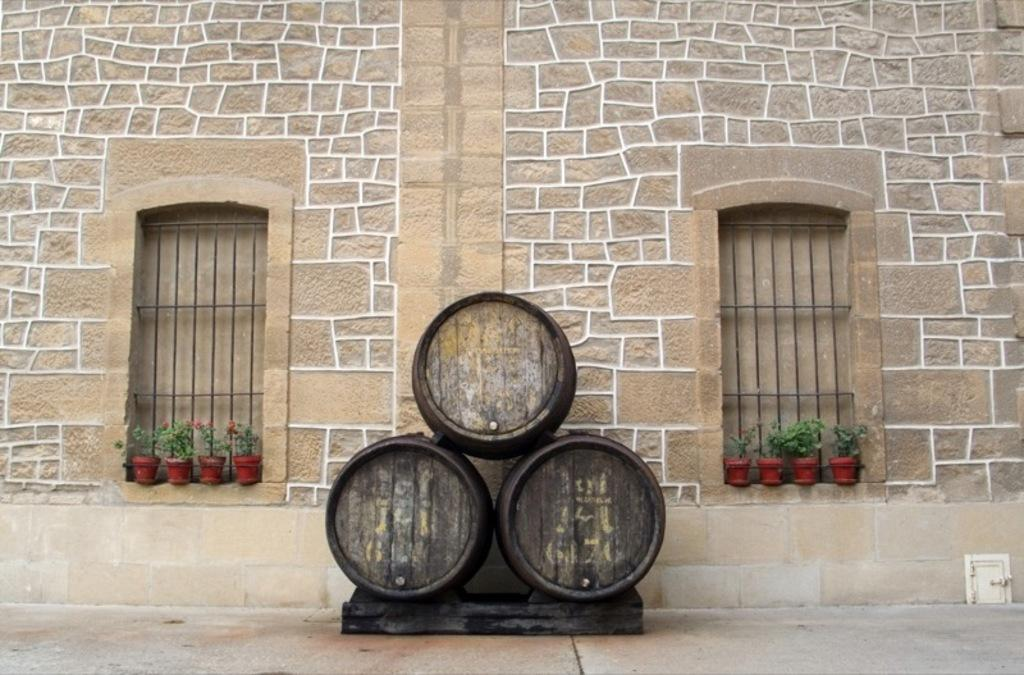What type of structure is present in the image? There is a building in the image. What feature can be seen on the building? The building has windows. What additional objects are visible in the image? There are flower pots in the image. Can you describe the black object on the floor? There is a black color object on the floor. What type of flower is growing in the company's cabbage patch in the image? There is no company or cabbage patch present in the image; it features a building, windows, flower pots, and a black object on the floor. 